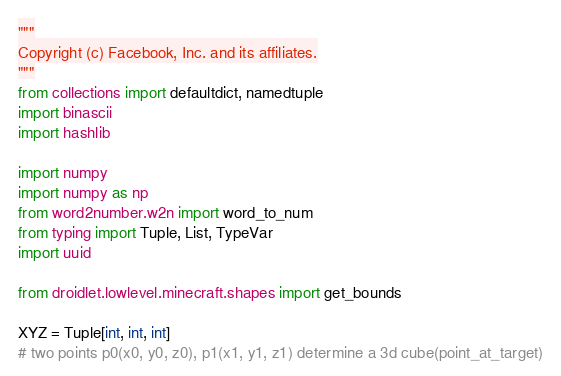Convert code to text. <code><loc_0><loc_0><loc_500><loc_500><_Python_>"""
Copyright (c) Facebook, Inc. and its affiliates.
"""
from collections import defaultdict, namedtuple
import binascii
import hashlib

import numpy
import numpy as np
from word2number.w2n import word_to_num
from typing import Tuple, List, TypeVar
import uuid

from droidlet.lowlevel.minecraft.shapes import get_bounds

XYZ = Tuple[int, int, int]
# two points p0(x0, y0, z0), p1(x1, y1, z1) determine a 3d cube(point_at_target)</code> 